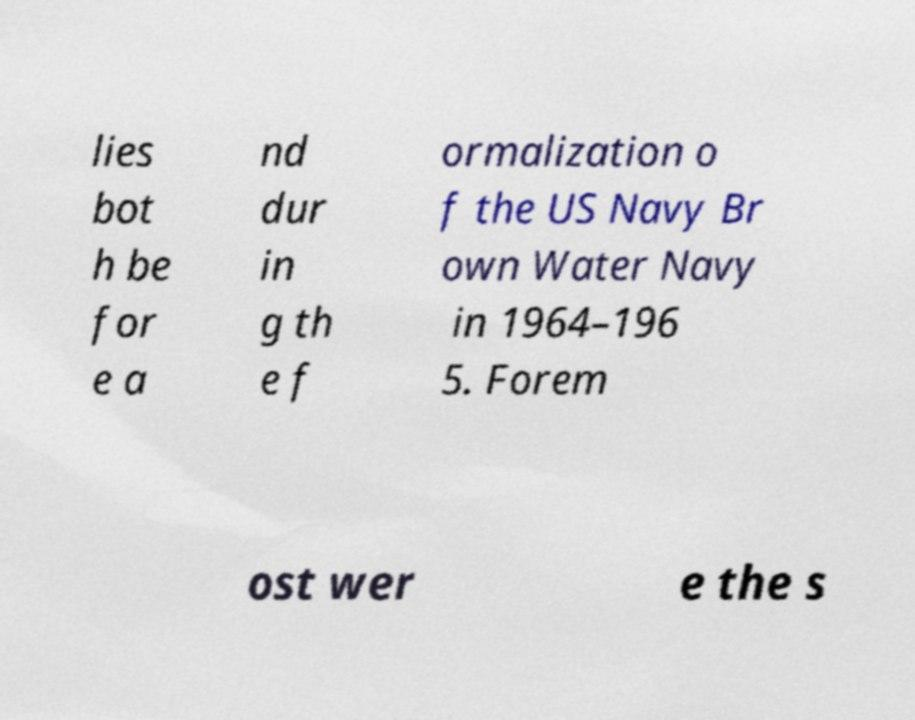For documentation purposes, I need the text within this image transcribed. Could you provide that? lies bot h be for e a nd dur in g th e f ormalization o f the US Navy Br own Water Navy in 1964–196 5. Forem ost wer e the s 